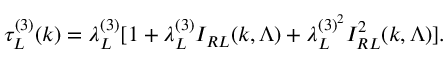Convert formula to latex. <formula><loc_0><loc_0><loc_500><loc_500>\tau _ { L } ^ { ( 3 ) } ( k ) = \lambda _ { L } ^ { ( 3 ) } [ 1 + \lambda _ { L } ^ { ( 3 ) } I _ { R L } ( k , \Lambda ) + \lambda _ { L } ^ { ( 3 ) ^ { 2 } } I _ { R L } ^ { 2 } ( k , \Lambda ) ] .</formula> 